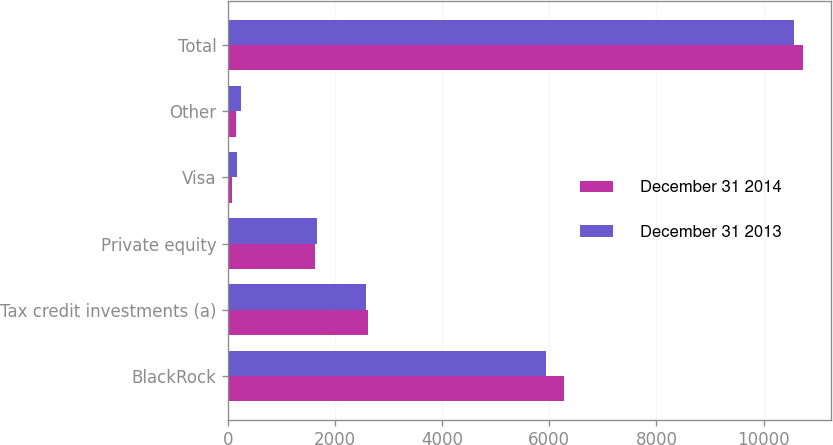<chart> <loc_0><loc_0><loc_500><loc_500><stacked_bar_chart><ecel><fcel>BlackRock<fcel>Tax credit investments (a)<fcel>Private equity<fcel>Visa<fcel>Other<fcel>Total<nl><fcel>December 31 2014<fcel>6265<fcel>2616<fcel>1615<fcel>77<fcel>155<fcel>10728<nl><fcel>December 31 2013<fcel>5940<fcel>2572<fcel>1656<fcel>158<fcel>234<fcel>10560<nl></chart> 